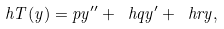<formula> <loc_0><loc_0><loc_500><loc_500>\ h T ( y ) = p y ^ { \prime \prime } + \ h q y ^ { \prime } + \ h r y ,</formula> 